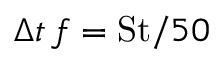Convert formula to latex. <formula><loc_0><loc_0><loc_500><loc_500>\Delta t \, f = S t / 5 0</formula> 